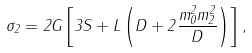Convert formula to latex. <formula><loc_0><loc_0><loc_500><loc_500>\sigma _ { 2 } = 2 G \left [ 3 S + L \left ( D + 2 { \frac { m _ { 0 } ^ { 2 } m _ { 2 } ^ { 2 } } { D } } \right ) \right ] ,</formula> 